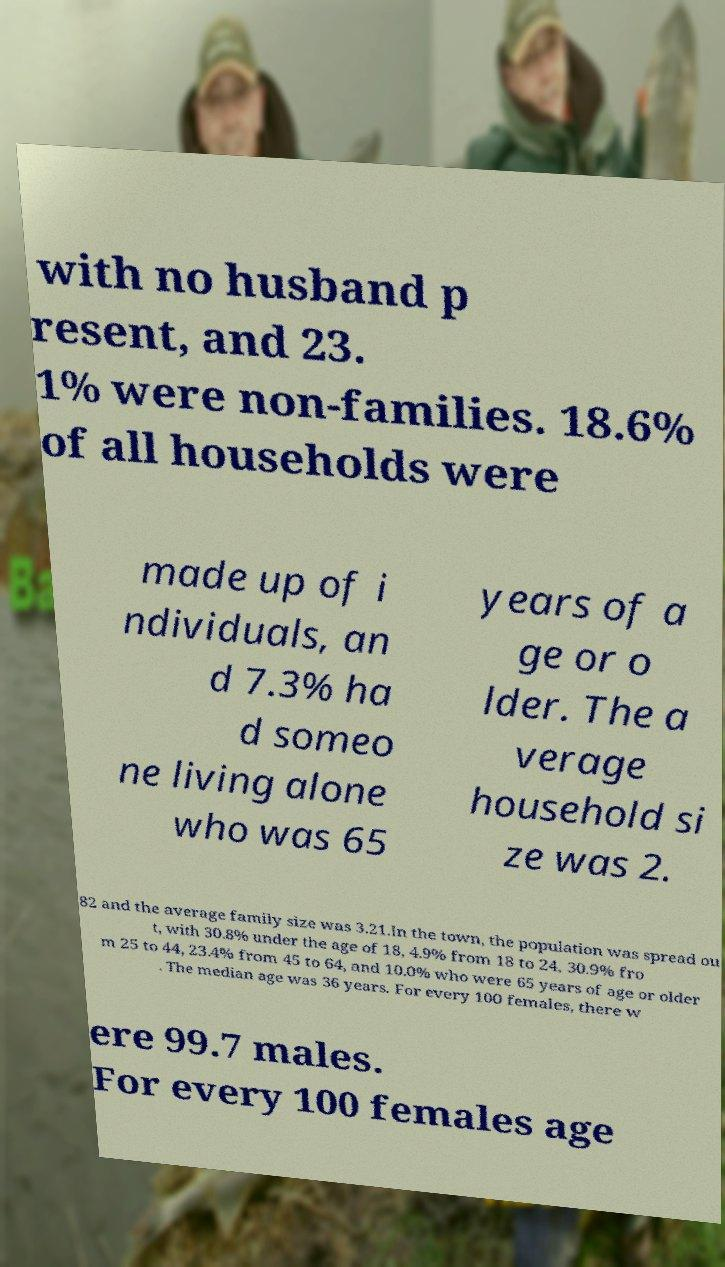I need the written content from this picture converted into text. Can you do that? with no husband p resent, and 23. 1% were non-families. 18.6% of all households were made up of i ndividuals, an d 7.3% ha d someo ne living alone who was 65 years of a ge or o lder. The a verage household si ze was 2. 82 and the average family size was 3.21.In the town, the population was spread ou t, with 30.8% under the age of 18, 4.9% from 18 to 24, 30.9% fro m 25 to 44, 23.4% from 45 to 64, and 10.0% who were 65 years of age or older . The median age was 36 years. For every 100 females, there w ere 99.7 males. For every 100 females age 